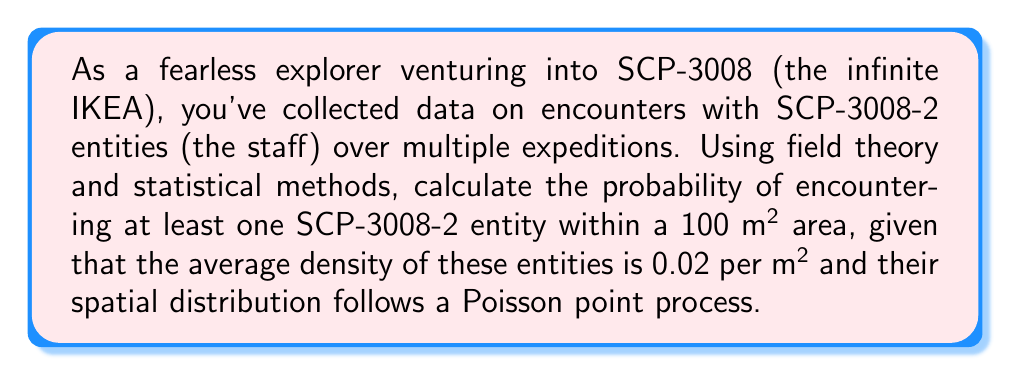Can you answer this question? To solve this problem, we'll use concepts from field theory and statistical methods, particularly the Poisson point process:

1. The Poisson point process is a model for randomly distributed points in space, which fits our scenario of SCP-3008-2 entities in the infinite IKEA.

2. The probability of encountering at least one entity is the complement of the probability of encountering no entities.

3. For a Poisson process, the probability of k events in a region of area A with intensity λ is given by:

   $$P(X = k) = \frac{(λA)^k e^{-λA}}{k!}$$

4. In our case:
   λ = 0.02 entities per m²
   A = 100 m²
   k = 0 (we want the probability of no encounters)

5. Let's calculate λA:
   $$λA = 0.02 \cdot 100 = 2$$

6. Now, we can calculate the probability of no encounters:

   $$P(X = 0) = \frac{2^0 e^{-2}}{0!} = e^{-2}$$

7. The probability of at least one encounter is the complement of this:

   $$P(X ≥ 1) = 1 - P(X = 0) = 1 - e^{-2}$$

8. Calculating this value:
   $$1 - e^{-2} ≈ 0.8646647167633873$$

Therefore, the probability of encountering at least one SCP-3008-2 entity in a 100 m² area is approximately 0.8647 or 86.47%.
Answer: $1 - e^{-2} ≈ 0.8647$ 